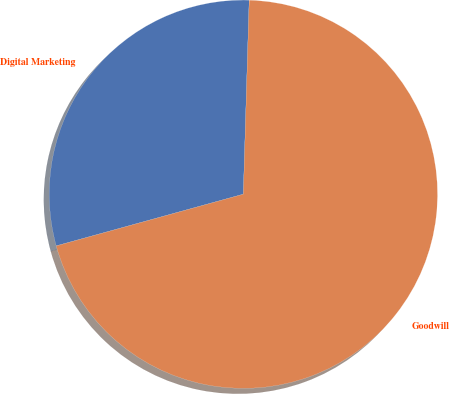Convert chart to OTSL. <chart><loc_0><loc_0><loc_500><loc_500><pie_chart><fcel>Digital Marketing<fcel>Goodwill<nl><fcel>29.77%<fcel>70.23%<nl></chart> 